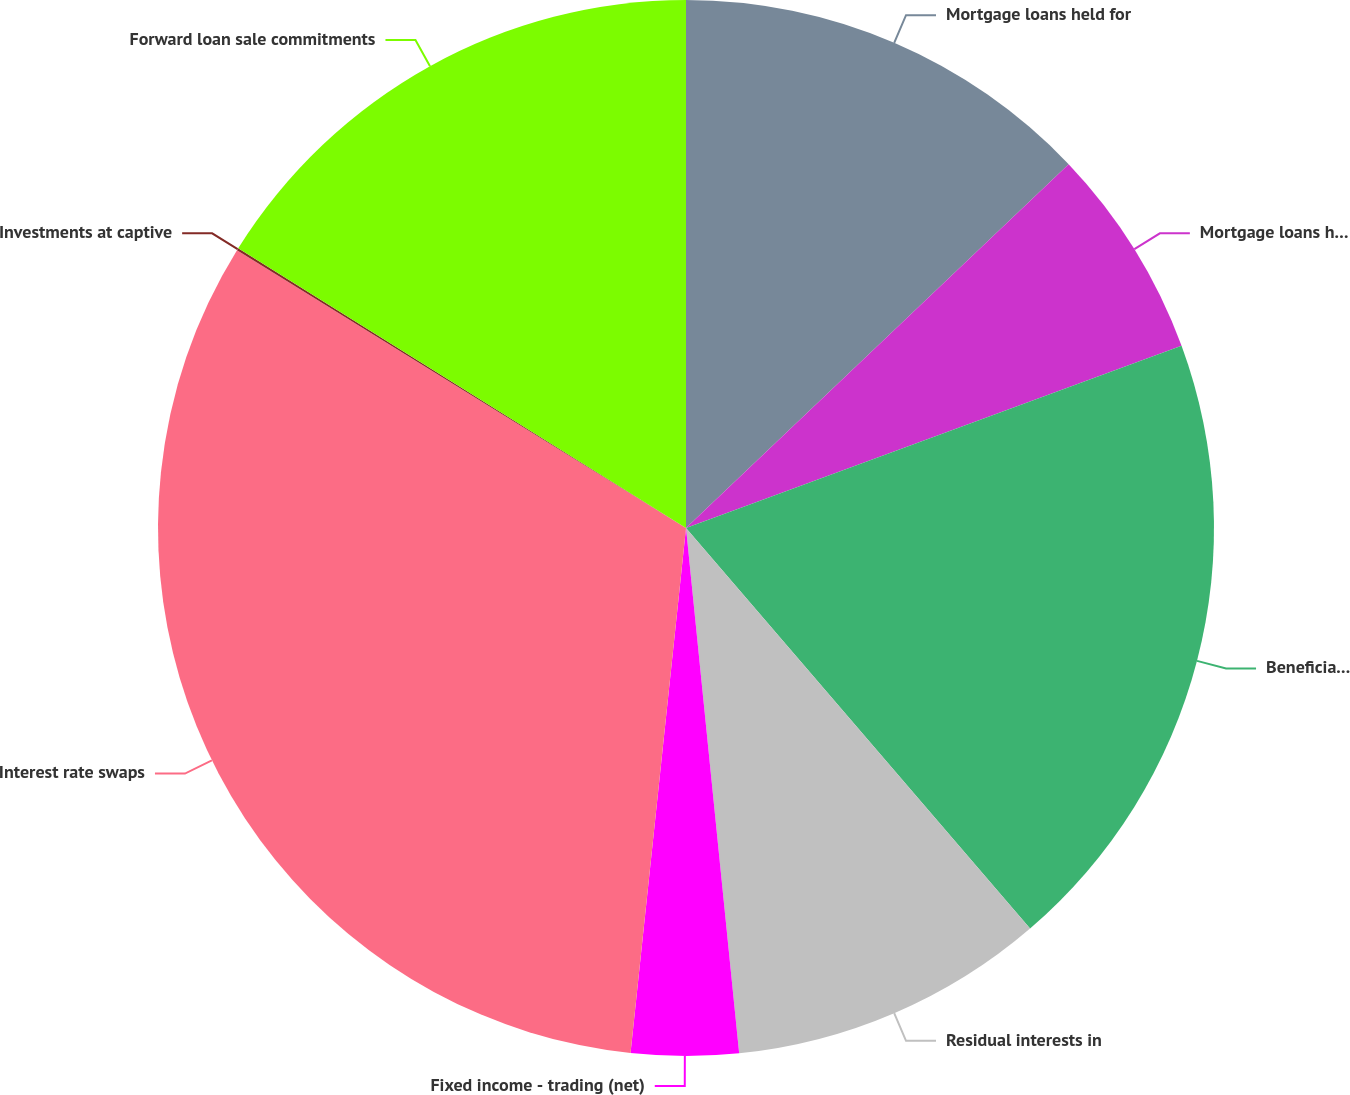Convert chart to OTSL. <chart><loc_0><loc_0><loc_500><loc_500><pie_chart><fcel>Mortgage loans held for<fcel>Mortgage loans held for sale<fcel>Beneficial interest in Trusts<fcel>Residual interests in<fcel>Fixed income - trading (net)<fcel>Interest rate swaps<fcel>Investments at captive<fcel>Forward loan sale commitments<nl><fcel>12.9%<fcel>6.49%<fcel>19.31%<fcel>9.69%<fcel>3.28%<fcel>32.14%<fcel>0.07%<fcel>16.11%<nl></chart> 